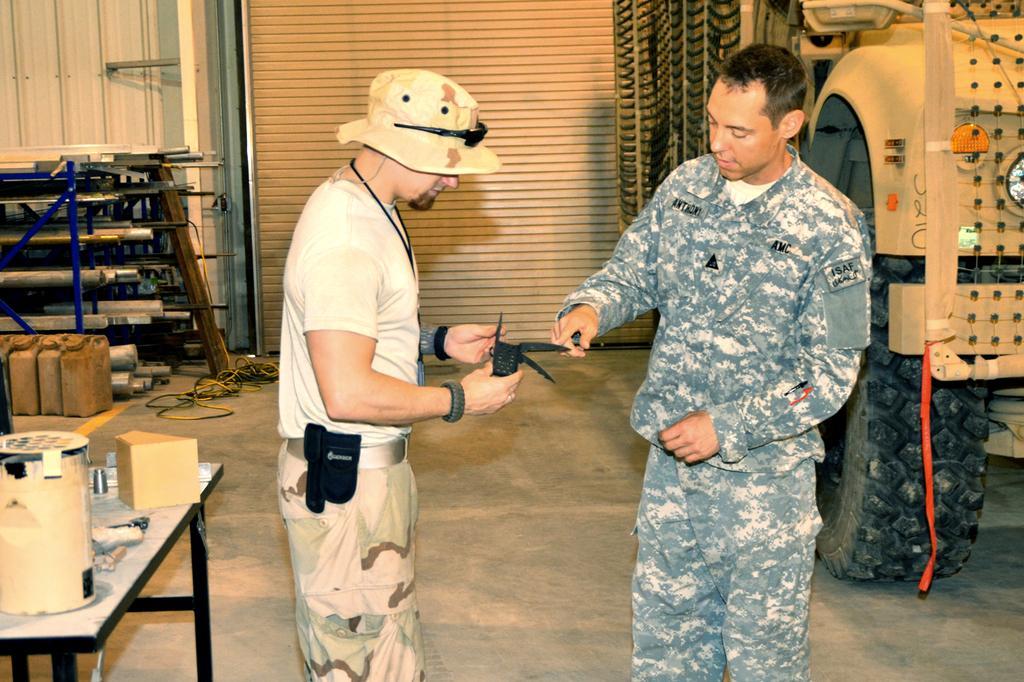Can you describe this image briefly? In this image there are two army personnel standing and talking with each other, on the right of the image there is a truck, on the left of the image there is a table and there are few ammunition on the floor. 